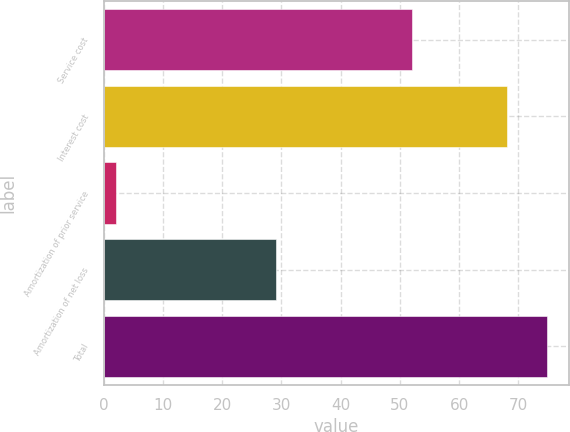Convert chart. <chart><loc_0><loc_0><loc_500><loc_500><bar_chart><fcel>Service cost<fcel>Interest cost<fcel>Amortization of prior service<fcel>Amortization of net loss<fcel>Total<nl><fcel>52<fcel>68<fcel>2<fcel>29<fcel>74.8<nl></chart> 